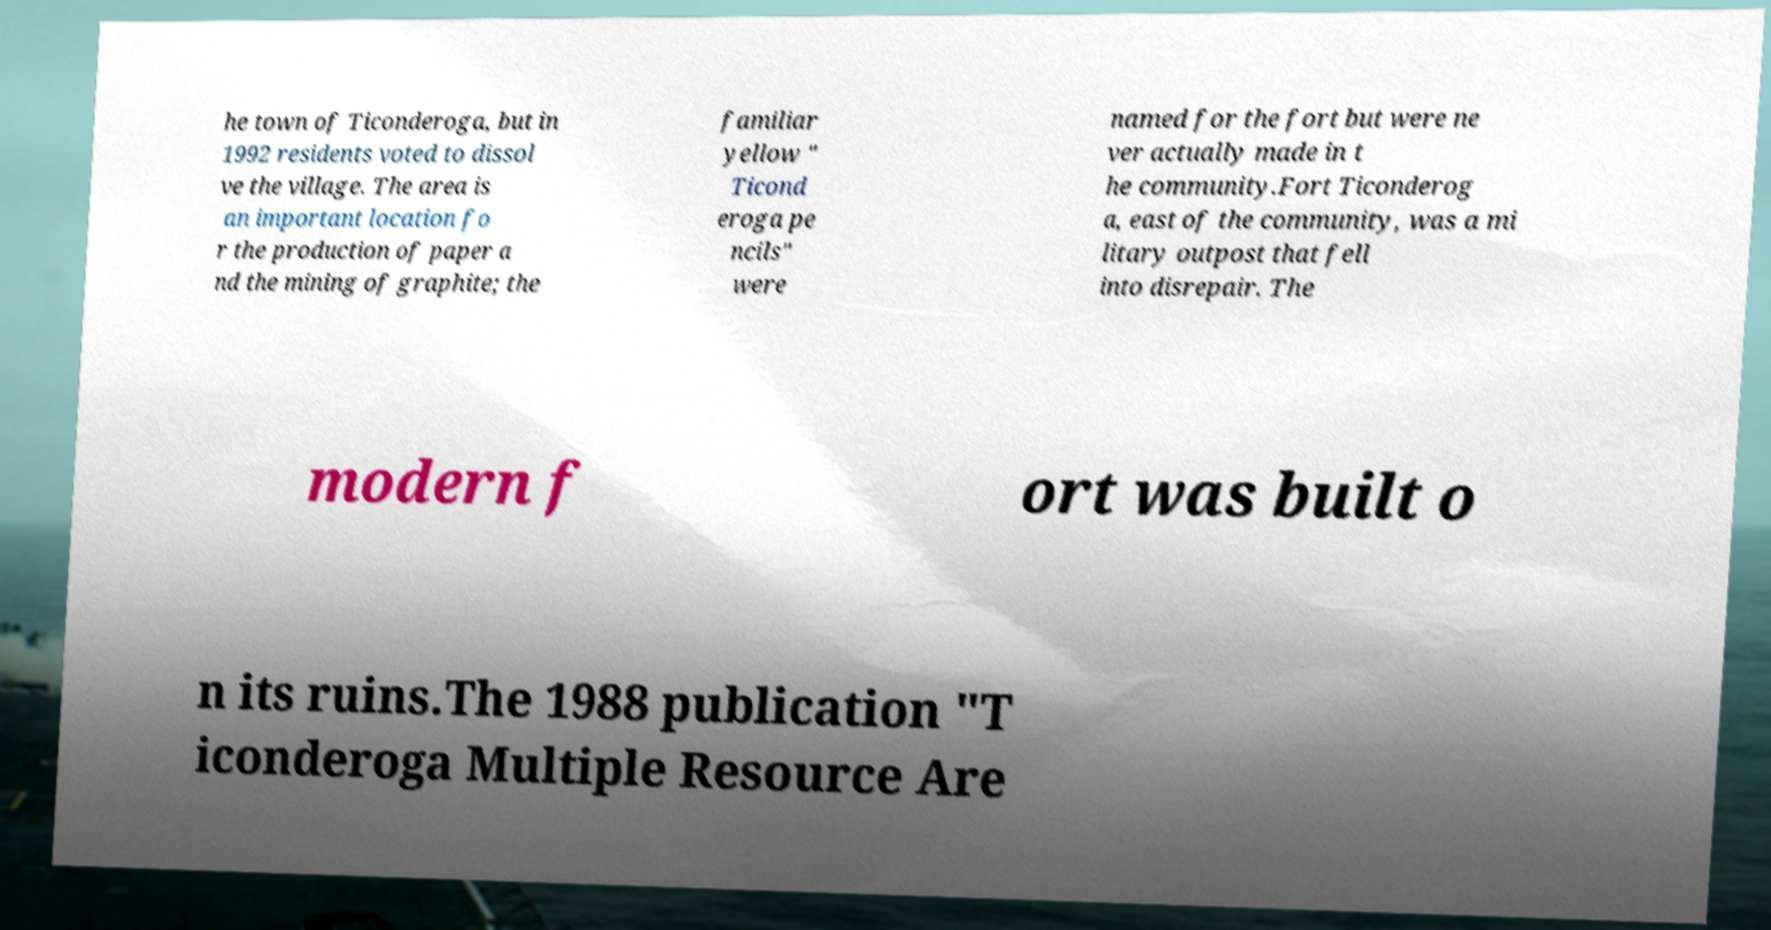Could you assist in decoding the text presented in this image and type it out clearly? he town of Ticonderoga, but in 1992 residents voted to dissol ve the village. The area is an important location fo r the production of paper a nd the mining of graphite; the familiar yellow " Ticond eroga pe ncils" were named for the fort but were ne ver actually made in t he community.Fort Ticonderog a, east of the community, was a mi litary outpost that fell into disrepair. The modern f ort was built o n its ruins.The 1988 publication "T iconderoga Multiple Resource Are 